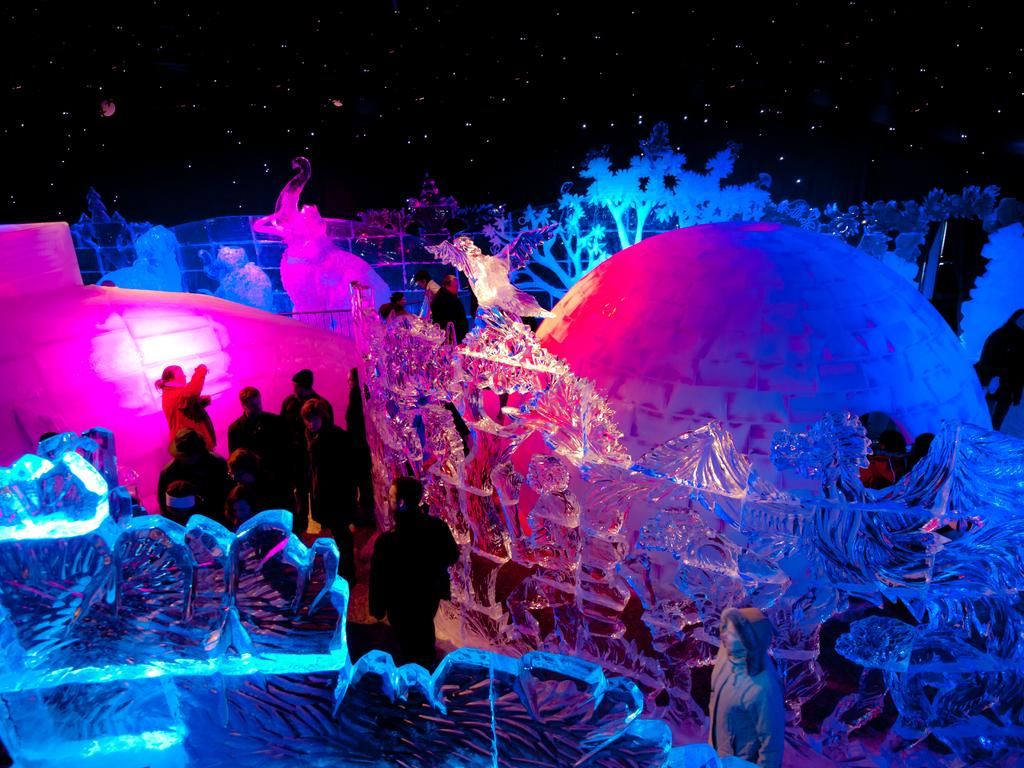Who or what can be seen in the image? There are people in the image. What kind of artistic creations are present in the image? There are sculptures made up of ice in the image. What can be seen in the background of the image? There are lights, trees, and the sky visible in the background of the image. What type of square is being used to power the ice sculptures in the image? There is no square or power source mentioned in the image; it features people and ice sculptures with lights and trees in the background. 